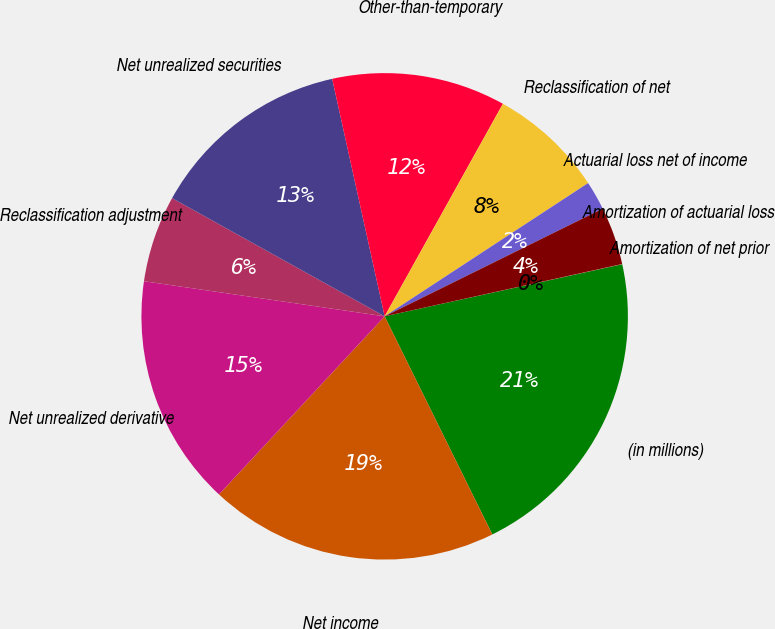Convert chart. <chart><loc_0><loc_0><loc_500><loc_500><pie_chart><fcel>(in millions)<fcel>Net income<fcel>Net unrealized derivative<fcel>Reclassification adjustment<fcel>Net unrealized securities<fcel>Other-than-temporary<fcel>Reclassification of net<fcel>Actuarial loss net of income<fcel>Amortization of actuarial loss<fcel>Amortization of net prior<nl><fcel>21.14%<fcel>19.22%<fcel>15.38%<fcel>5.77%<fcel>13.46%<fcel>11.54%<fcel>7.69%<fcel>1.93%<fcel>3.85%<fcel>0.01%<nl></chart> 